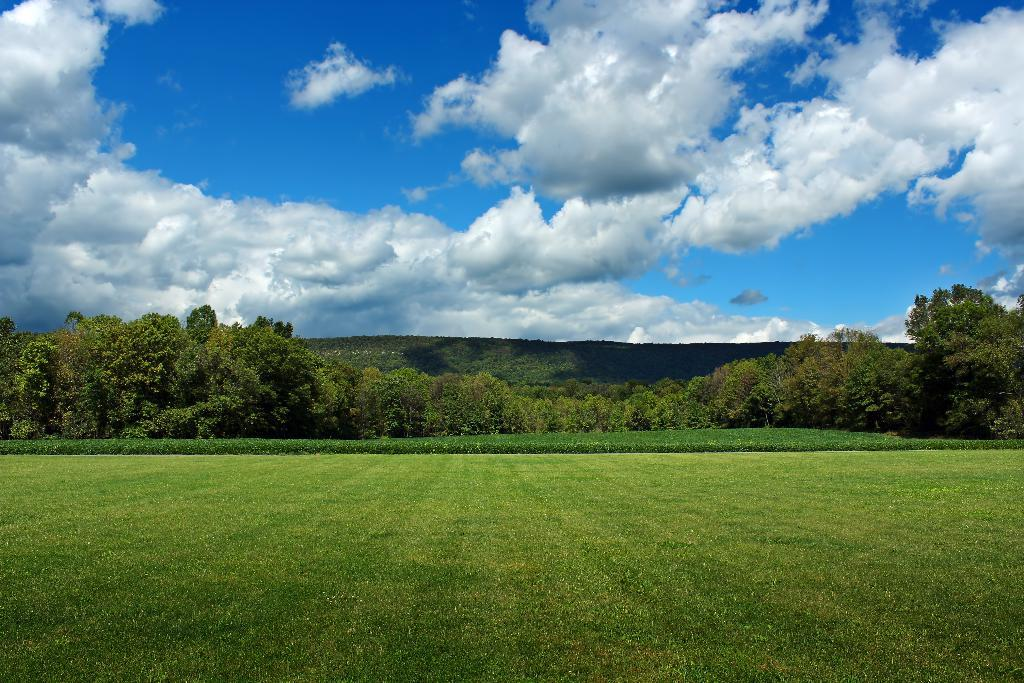What type of vegetation can be seen in the image? There is grass in the image. What other natural elements are present in the image? There are trees and mountains in the image. What is visible in the background of the image? The sky is visible in the image. What can be observed in the sky? Clouds are present in the sky. How many babies are present in the image? There are no babies present in the image. What type of company is depicted in the image? There is no company depicted in the image; it features natural elements such as grass, trees, mountains, sky, and clouds. 